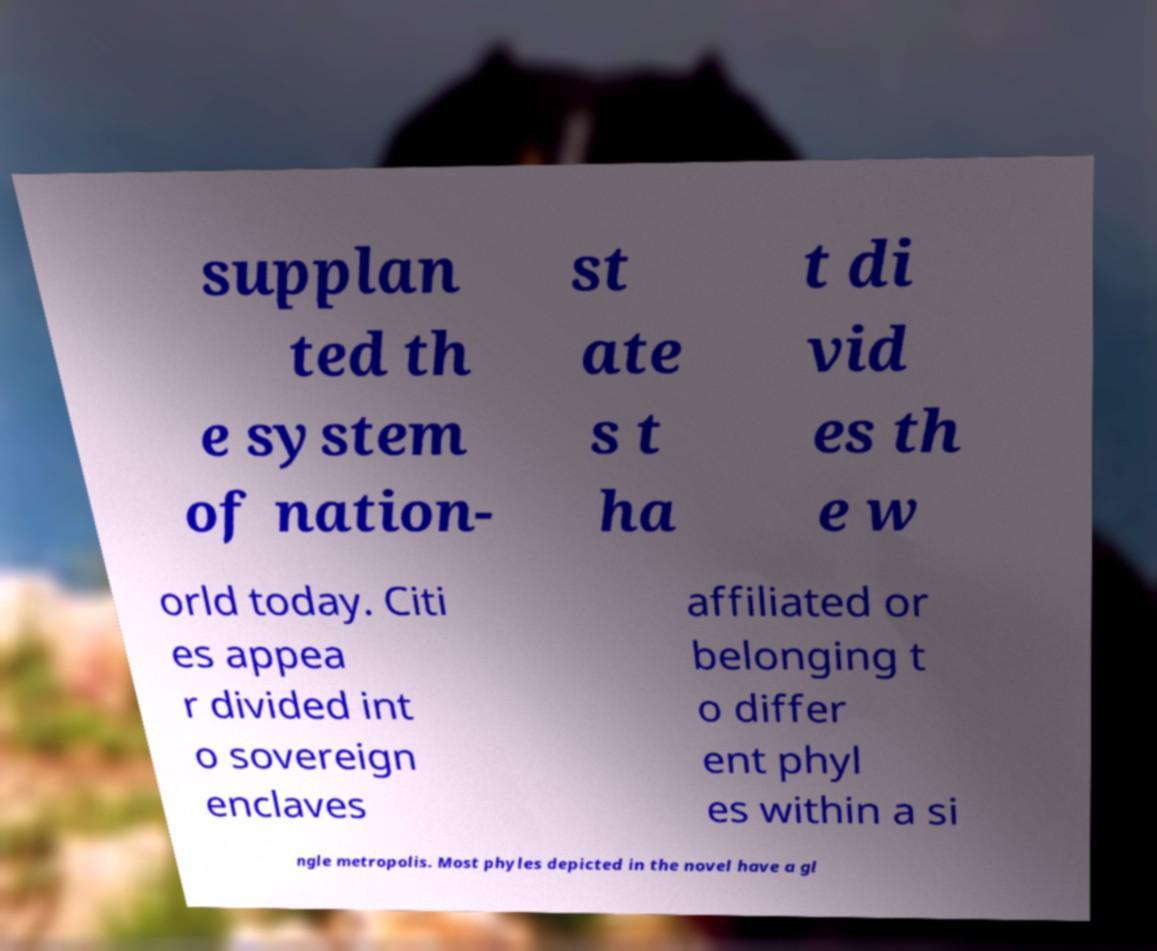Please read and relay the text visible in this image. What does it say? supplan ted th e system of nation- st ate s t ha t di vid es th e w orld today. Citi es appea r divided int o sovereign enclaves affiliated or belonging t o differ ent phyl es within a si ngle metropolis. Most phyles depicted in the novel have a gl 